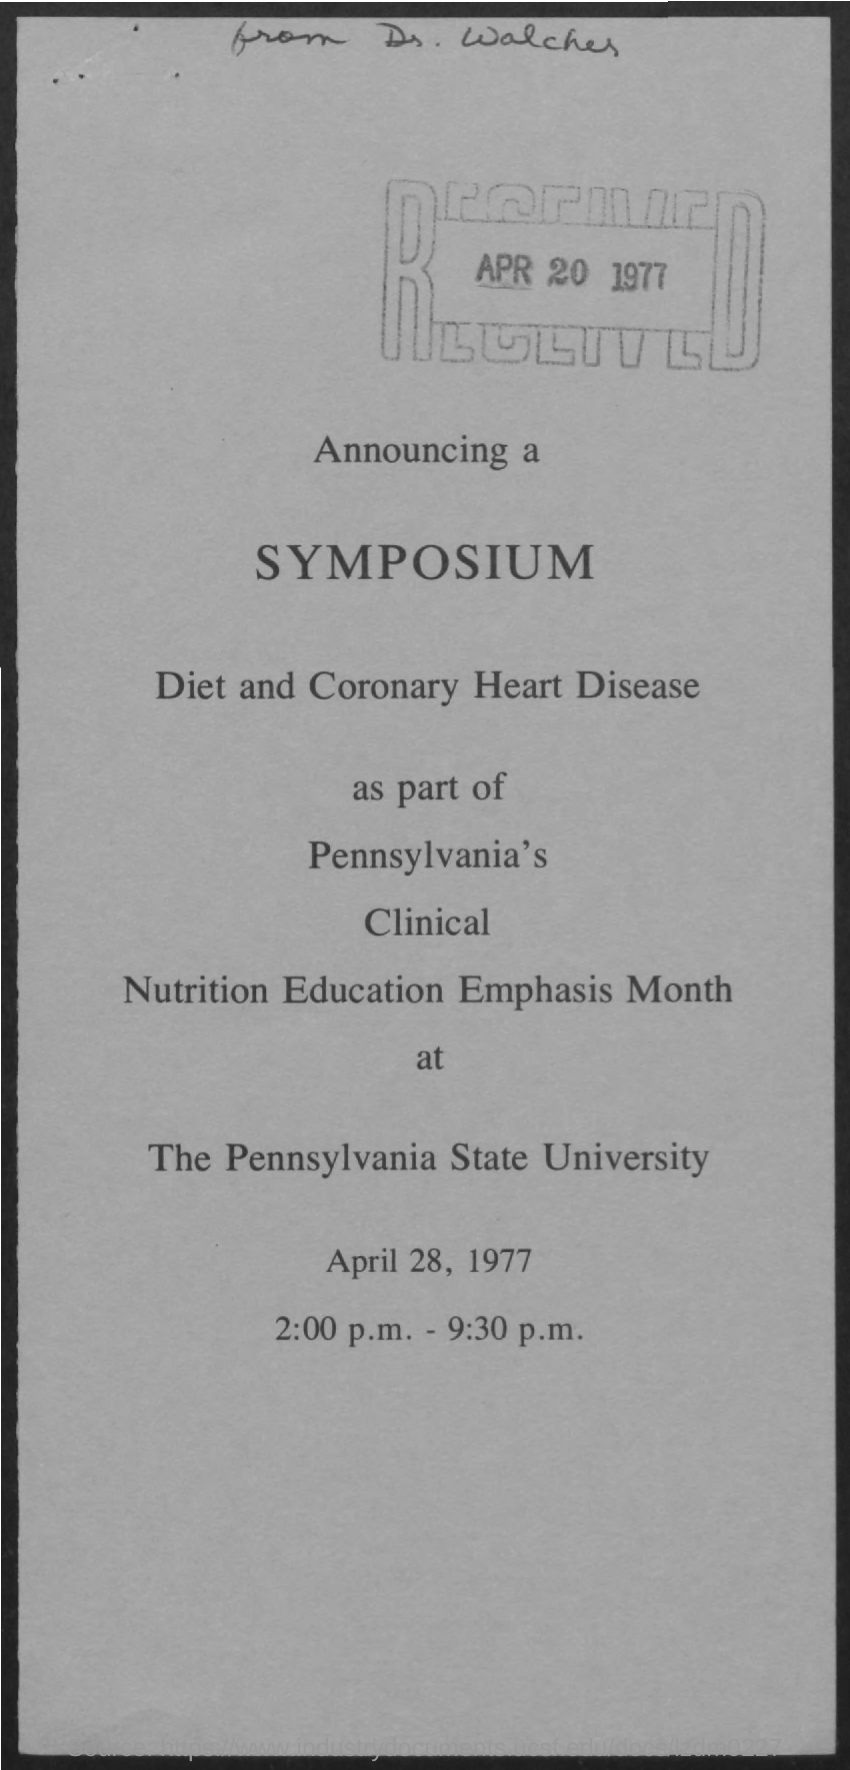What date is written in rectangle box
Offer a very short reply. APR 20 1977. Which University name is given is this announcement
Make the answer very short. The Pennsylvania State University. 